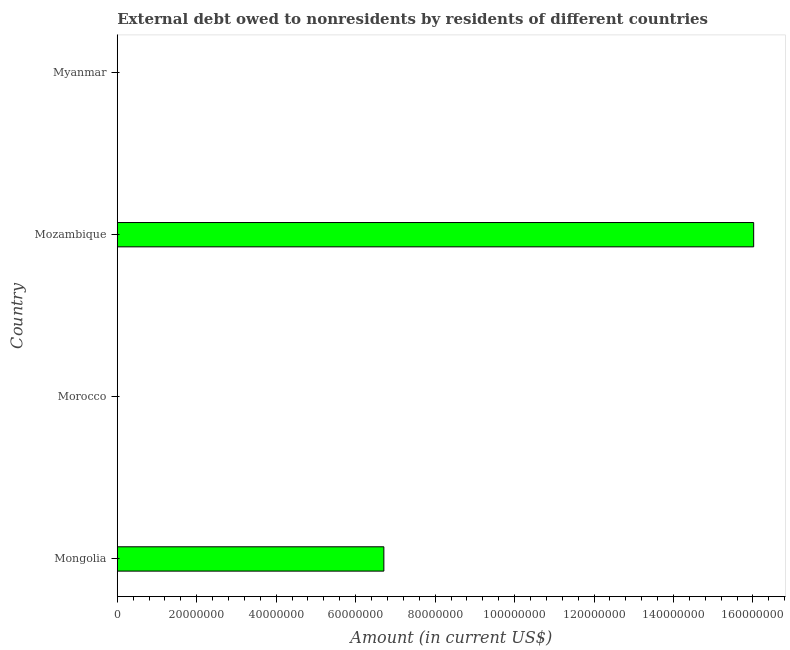Does the graph contain any zero values?
Your answer should be very brief. Yes. What is the title of the graph?
Your response must be concise. External debt owed to nonresidents by residents of different countries. What is the label or title of the X-axis?
Provide a succinct answer. Amount (in current US$). What is the label or title of the Y-axis?
Your answer should be very brief. Country. What is the debt in Mozambique?
Your response must be concise. 1.60e+08. Across all countries, what is the maximum debt?
Provide a succinct answer. 1.60e+08. Across all countries, what is the minimum debt?
Offer a terse response. 0. In which country was the debt maximum?
Make the answer very short. Mozambique. What is the sum of the debt?
Ensure brevity in your answer.  2.27e+08. What is the average debt per country?
Offer a terse response. 5.68e+07. What is the median debt?
Your answer should be very brief. 3.35e+07. What is the ratio of the debt in Mongolia to that in Mozambique?
Your answer should be compact. 0.42. Is the difference between the debt in Mongolia and Mozambique greater than the difference between any two countries?
Ensure brevity in your answer.  No. What is the difference between the highest and the lowest debt?
Your response must be concise. 1.60e+08. How many bars are there?
Ensure brevity in your answer.  2. What is the difference between two consecutive major ticks on the X-axis?
Offer a very short reply. 2.00e+07. What is the Amount (in current US$) in Mongolia?
Keep it short and to the point. 6.71e+07. What is the Amount (in current US$) of Mozambique?
Provide a succinct answer. 1.60e+08. What is the difference between the Amount (in current US$) in Mongolia and Mozambique?
Provide a short and direct response. -9.31e+07. What is the ratio of the Amount (in current US$) in Mongolia to that in Mozambique?
Give a very brief answer. 0.42. 